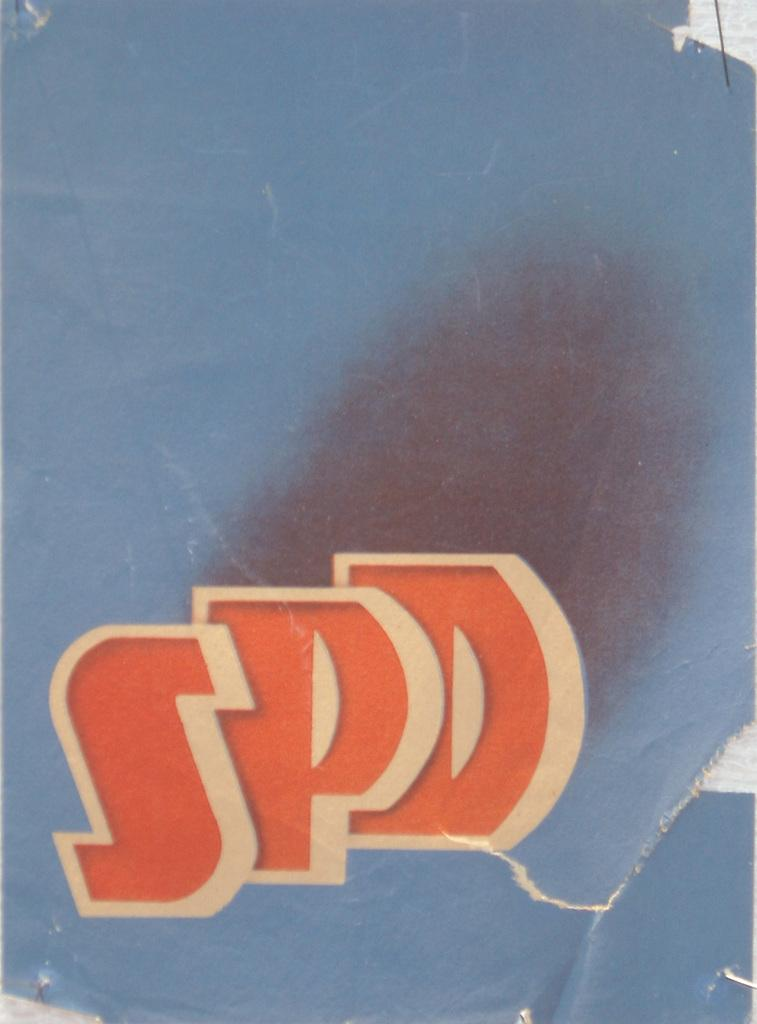<image>
Present a compact description of the photo's key features. Twriting SPD appears on a a tattered piece of paper with a blue background. 